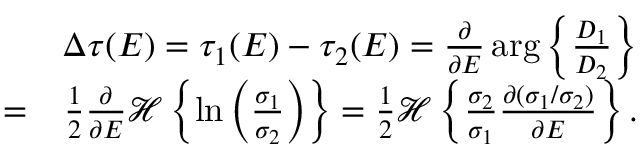Convert formula to latex. <formula><loc_0><loc_0><loc_500><loc_500>\begin{array} { r l r } & { \Delta \tau ( E ) = \tau _ { 1 } ( E ) - \tau _ { 2 } ( E ) = \frac { \partial } { \partial E } \arg \left \{ \frac { D _ { 1 } } { D _ { 2 } } \right \} } \\ & { = } & { \frac { 1 } { 2 } \frac { \partial } { \partial E } \mathcal { H } \left \{ \ln \left ( \frac { \sigma _ { 1 } } { \sigma _ { 2 } } \right ) \right \} = \frac { 1 } { 2 } \mathcal { H } \left \{ \frac { \sigma _ { 2 } } { \sigma _ { 1 } } \frac { \partial ( \sigma _ { 1 } / \sigma _ { 2 } ) } { \partial E } \right \} . } \end{array}</formula> 